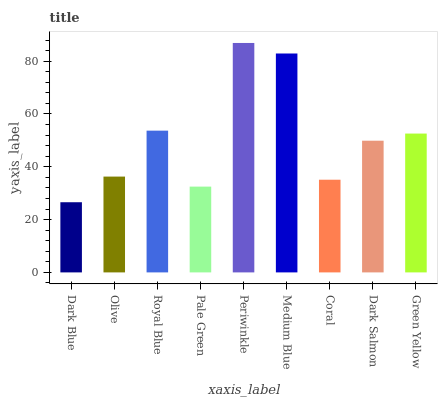Is Dark Blue the minimum?
Answer yes or no. Yes. Is Periwinkle the maximum?
Answer yes or no. Yes. Is Olive the minimum?
Answer yes or no. No. Is Olive the maximum?
Answer yes or no. No. Is Olive greater than Dark Blue?
Answer yes or no. Yes. Is Dark Blue less than Olive?
Answer yes or no. Yes. Is Dark Blue greater than Olive?
Answer yes or no. No. Is Olive less than Dark Blue?
Answer yes or no. No. Is Dark Salmon the high median?
Answer yes or no. Yes. Is Dark Salmon the low median?
Answer yes or no. Yes. Is Coral the high median?
Answer yes or no. No. Is Dark Blue the low median?
Answer yes or no. No. 